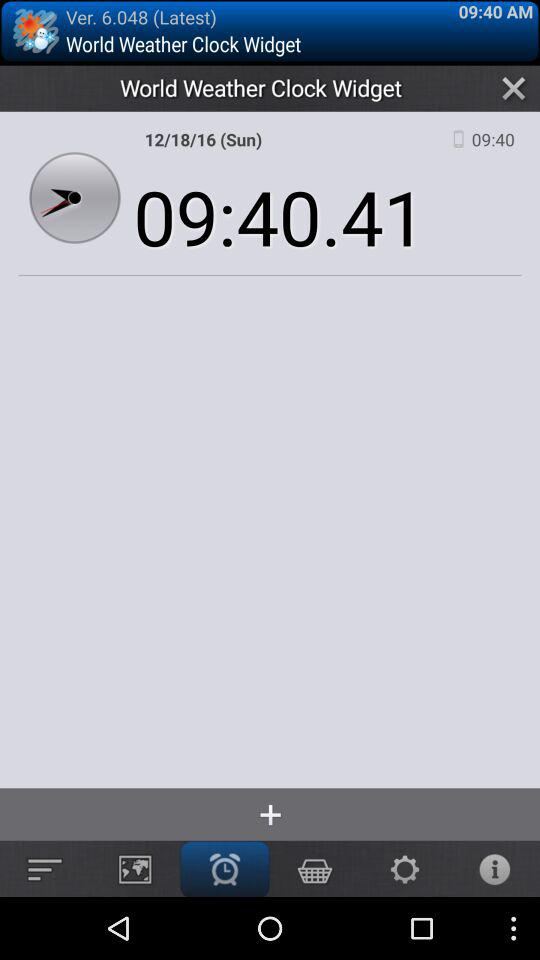What is the difference in time between the two displayed times, 09:40.41 and 09:40?
Answer the question using a single word or phrase. 0.41 